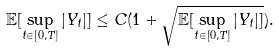<formula> <loc_0><loc_0><loc_500><loc_500>\mathbb { E } [ \sup _ { t \in [ 0 , T ] } | Y _ { t } | ] \leq C ( 1 + \sqrt { \mathbb { E } [ \sup _ { t \in [ 0 , T ] } | Y _ { t } | ] } ) .</formula> 